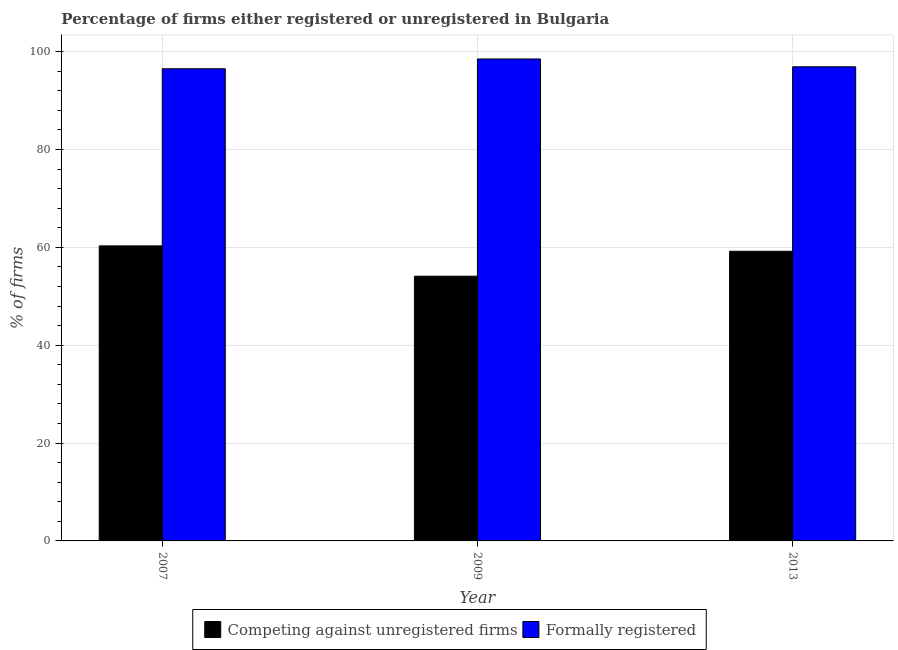How many different coloured bars are there?
Your answer should be very brief. 2. How many groups of bars are there?
Provide a succinct answer. 3. Are the number of bars per tick equal to the number of legend labels?
Your response must be concise. Yes. How many bars are there on the 1st tick from the left?
Keep it short and to the point. 2. How many bars are there on the 1st tick from the right?
Give a very brief answer. 2. In how many cases, is the number of bars for a given year not equal to the number of legend labels?
Ensure brevity in your answer.  0. What is the percentage of formally registered firms in 2007?
Offer a terse response. 96.5. Across all years, what is the maximum percentage of registered firms?
Keep it short and to the point. 60.3. Across all years, what is the minimum percentage of registered firms?
Your answer should be compact. 54.1. What is the total percentage of formally registered firms in the graph?
Your response must be concise. 291.9. What is the difference between the percentage of formally registered firms in 2009 and that in 2013?
Your response must be concise. 1.6. What is the difference between the percentage of formally registered firms in 2009 and the percentage of registered firms in 2013?
Give a very brief answer. 1.6. What is the average percentage of registered firms per year?
Ensure brevity in your answer.  57.87. In how many years, is the percentage of formally registered firms greater than 16 %?
Offer a very short reply. 3. What is the ratio of the percentage of formally registered firms in 2007 to that in 2009?
Make the answer very short. 0.98. What is the difference between the highest and the second highest percentage of registered firms?
Make the answer very short. 1.1. What does the 1st bar from the left in 2013 represents?
Your response must be concise. Competing against unregistered firms. What does the 2nd bar from the right in 2007 represents?
Keep it short and to the point. Competing against unregistered firms. How many bars are there?
Provide a short and direct response. 6. Are all the bars in the graph horizontal?
Your response must be concise. No. What is the difference between two consecutive major ticks on the Y-axis?
Offer a terse response. 20. Where does the legend appear in the graph?
Make the answer very short. Bottom center. What is the title of the graph?
Your answer should be compact. Percentage of firms either registered or unregistered in Bulgaria. What is the label or title of the Y-axis?
Offer a terse response. % of firms. What is the % of firms of Competing against unregistered firms in 2007?
Make the answer very short. 60.3. What is the % of firms in Formally registered in 2007?
Provide a succinct answer. 96.5. What is the % of firms in Competing against unregistered firms in 2009?
Give a very brief answer. 54.1. What is the % of firms in Formally registered in 2009?
Provide a short and direct response. 98.5. What is the % of firms of Competing against unregistered firms in 2013?
Your answer should be compact. 59.2. What is the % of firms of Formally registered in 2013?
Provide a short and direct response. 96.9. Across all years, what is the maximum % of firms of Competing against unregistered firms?
Provide a short and direct response. 60.3. Across all years, what is the maximum % of firms of Formally registered?
Offer a very short reply. 98.5. Across all years, what is the minimum % of firms in Competing against unregistered firms?
Make the answer very short. 54.1. Across all years, what is the minimum % of firms in Formally registered?
Provide a short and direct response. 96.5. What is the total % of firms of Competing against unregistered firms in the graph?
Ensure brevity in your answer.  173.6. What is the total % of firms in Formally registered in the graph?
Provide a short and direct response. 291.9. What is the difference between the % of firms of Formally registered in 2007 and that in 2009?
Give a very brief answer. -2. What is the difference between the % of firms of Formally registered in 2007 and that in 2013?
Provide a succinct answer. -0.4. What is the difference between the % of firms in Competing against unregistered firms in 2009 and that in 2013?
Your answer should be compact. -5.1. What is the difference between the % of firms in Competing against unregistered firms in 2007 and the % of firms in Formally registered in 2009?
Give a very brief answer. -38.2. What is the difference between the % of firms of Competing against unregistered firms in 2007 and the % of firms of Formally registered in 2013?
Provide a short and direct response. -36.6. What is the difference between the % of firms in Competing against unregistered firms in 2009 and the % of firms in Formally registered in 2013?
Provide a short and direct response. -42.8. What is the average % of firms in Competing against unregistered firms per year?
Offer a very short reply. 57.87. What is the average % of firms in Formally registered per year?
Make the answer very short. 97.3. In the year 2007, what is the difference between the % of firms of Competing against unregistered firms and % of firms of Formally registered?
Ensure brevity in your answer.  -36.2. In the year 2009, what is the difference between the % of firms in Competing against unregistered firms and % of firms in Formally registered?
Offer a terse response. -44.4. In the year 2013, what is the difference between the % of firms of Competing against unregistered firms and % of firms of Formally registered?
Offer a terse response. -37.7. What is the ratio of the % of firms of Competing against unregistered firms in 2007 to that in 2009?
Your response must be concise. 1.11. What is the ratio of the % of firms in Formally registered in 2007 to that in 2009?
Your answer should be compact. 0.98. What is the ratio of the % of firms in Competing against unregistered firms in 2007 to that in 2013?
Provide a succinct answer. 1.02. What is the ratio of the % of firms in Competing against unregistered firms in 2009 to that in 2013?
Keep it short and to the point. 0.91. What is the ratio of the % of firms of Formally registered in 2009 to that in 2013?
Your answer should be very brief. 1.02. What is the difference between the highest and the second highest % of firms in Formally registered?
Make the answer very short. 1.6. 